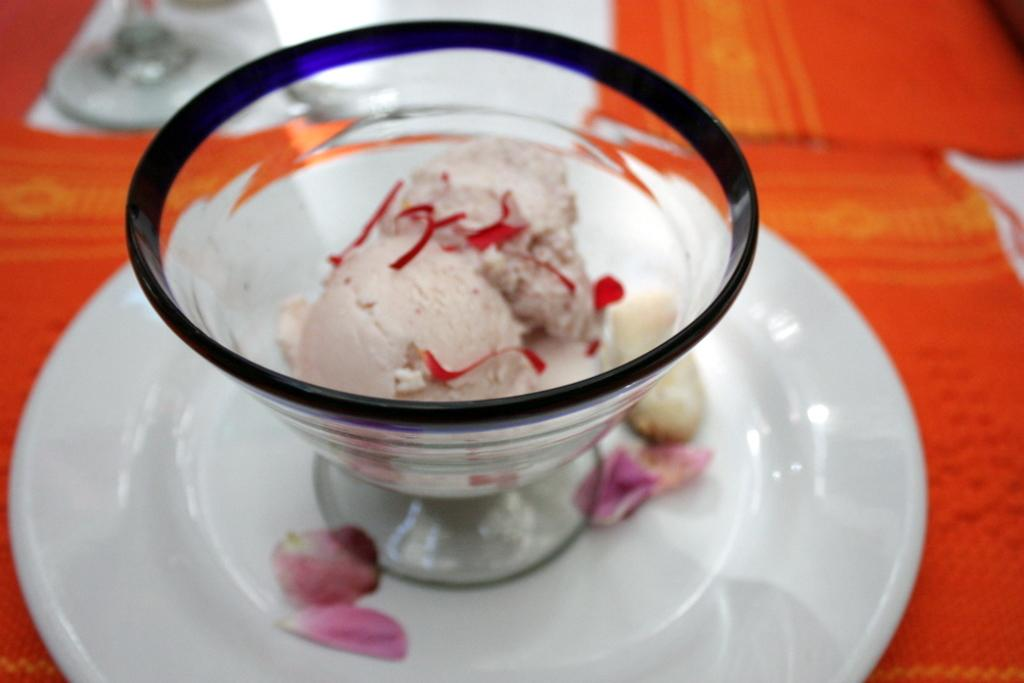What is in the cup that is visible in the image? There is a scoop of ice cream in a cup in the image. What is the cup placed on? The cup is placed on a saucer. What decorative element is present on the saucer? There are petals of a rose on the saucer. What type of offer is being made by the beast in the image? There is no beast present in the image, so no offer can be made. 